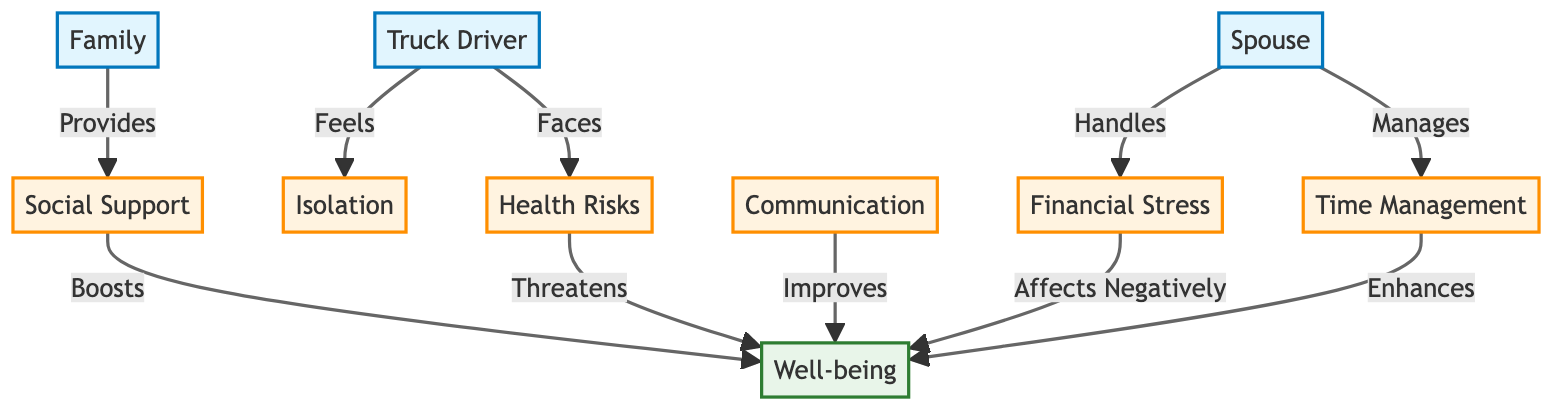What is the main factor affecting well-being negatively? The diagram shows that financial stress is linked with a negative impact on well-being. It specifically states that financial stress affects well-being negatively.
Answer: financial stress How many entities are represented in the diagram? The diagram represents three entities: truck driver, spouse, and family. Therefore, by counting these entities, we arrive at a total of three.
Answer: 3 What does the spouse manage related to financial challenges? The diagram indicates that the spouse handles financial stress, which is their specific responsibility in relation to managing the finances of the family.
Answer: financial stress Which factor is listed as enhancing well-being? According to the diagram, time management is mentioned as enhancing well-being. This implies that effective time management can lead to improved mental health and overall well-being.
Answer: time management How does social support relate to well-being in the diagram? The diagram states that social support boosts well-being, suggesting that having a strong social network positively influences the mental health of the individuals involved.
Answer: boosts What is the relationship between communication and well-being? The diagram depicts that communication improves well-being, indicating that effective communication among family members can have a positive effect on mental health.
Answer: improves Which factor threatens the well-being of the truck driver? The diagram clearly states that health risks threaten the well-being of the truck driver, indicating a negative impact on their mental health due to various health concerns.
Answer: health risks In what way does isolation affect the truck driver? The diagram indicates that the truck driver feels isolation, which implies a direct relationship where isolation is a prominent factor influencing their mental health.
Answer: feels What role does the family play in relation to social support? The diagram specifies that family provides social support, indicating that family members are a source of emotional and practical assistance for the truck driver and spouse.
Answer: provides 